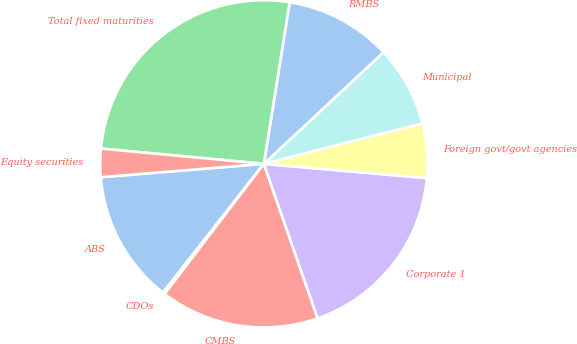Convert chart to OTSL. <chart><loc_0><loc_0><loc_500><loc_500><pie_chart><fcel>ABS<fcel>CDOs<fcel>CMBS<fcel>Corporate 1<fcel>Foreign govt/govt agencies<fcel>Municipal<fcel>RMBS<fcel>Total fixed maturities<fcel>Equity securities<nl><fcel>13.12%<fcel>0.21%<fcel>15.7%<fcel>18.28%<fcel>5.37%<fcel>7.96%<fcel>10.54%<fcel>26.03%<fcel>2.79%<nl></chart> 